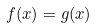<formula> <loc_0><loc_0><loc_500><loc_500>f ( x ) = g ( x )</formula> 